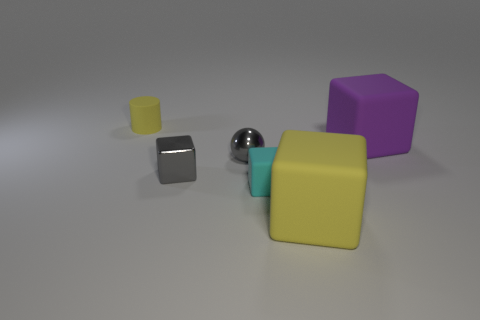Is there any pattern in the arrangement of the objects? The objects seem to be arranged with no specific pattern, placed at varying distances from each other on a flat surface. They form a somewhat diagonal line across the image. Can you infer anything about the lighting conditions in the scene? The lighting appears to be soft and diffused, likely from an overhead source, as evidenced by the gentle shadows beneath each object and the visible reflections, especially on the shiny sphere. 